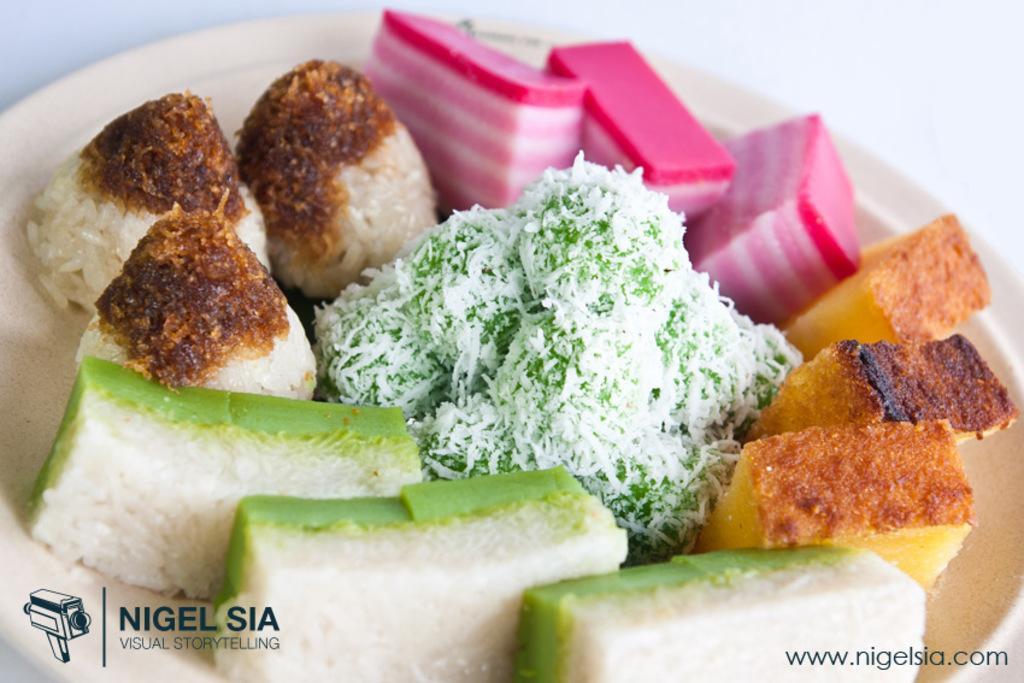In one or two sentences, can you explain what this image depicts? In this image we can see a food in a plate placed on the table. 